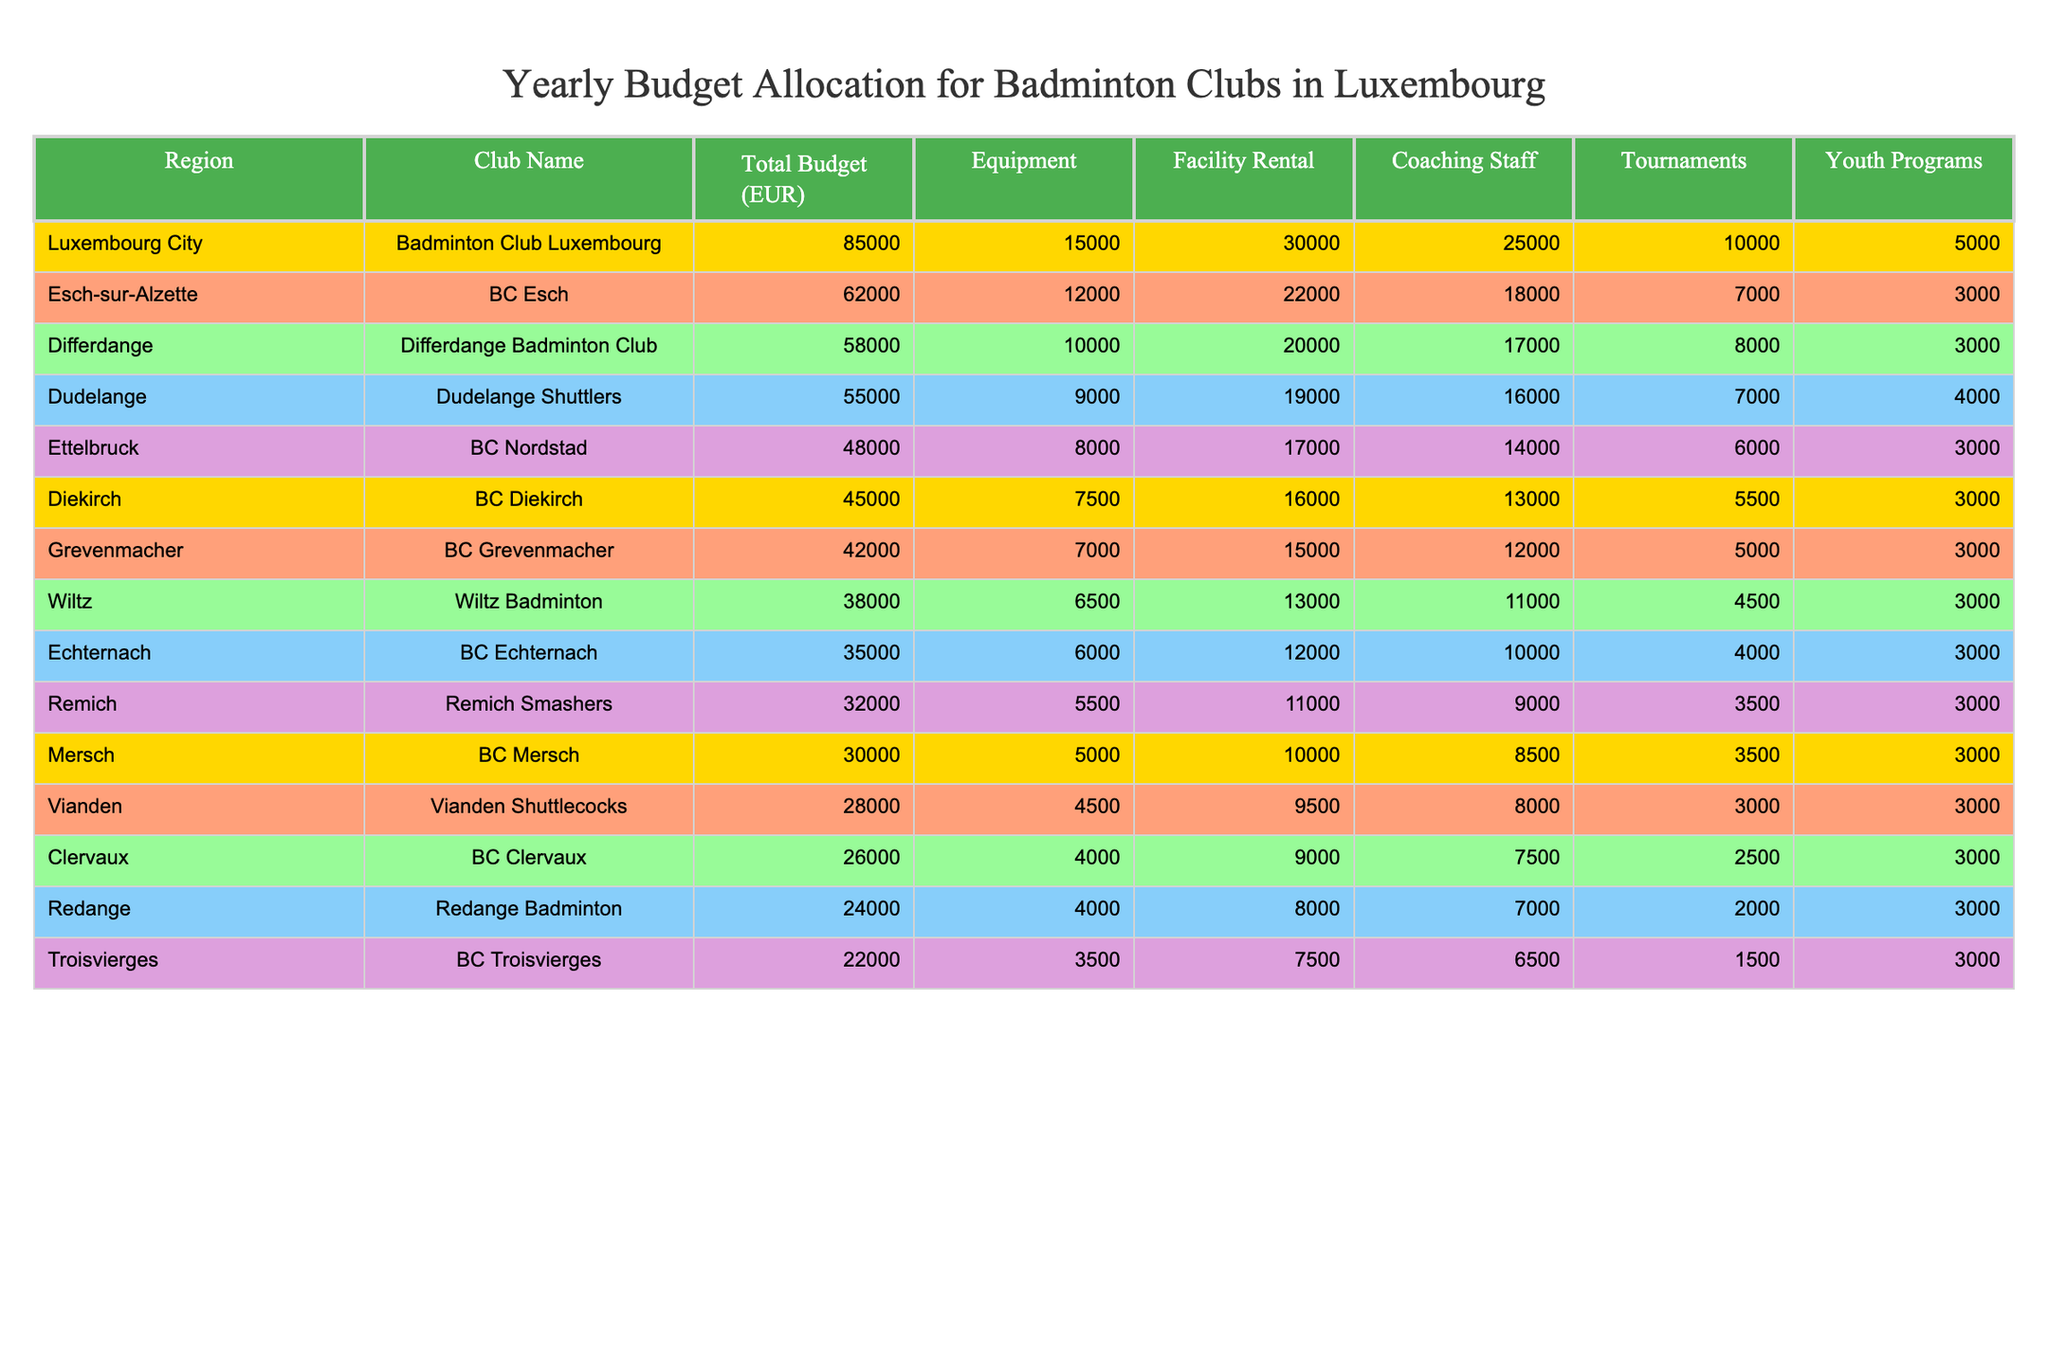What is the total budget for the Badminton Club Luxembourg? The total budget for the Badminton Club Luxembourg is listed in the table under "Total Budget (EUR)" for the region "Luxembourg City," which shows a value of 85,000 EUR.
Answer: 85,000 EUR Which club has the highest budget allocation? By examining the "Total Budget (EUR)" column, it is clear that the Badminton Club Luxembourg has the highest total budget of 85,000 EUR, compared to other clubs.
Answer: Badminton Club Luxembourg What percentage of the total budget does coaching staff make up for BC Esch? The total budget for BC Esch is 62,000 EUR, and the coaching staff allocation is 18,000 EUR. To find the percentage, divide 18,000 by 62,000 and multiply by 100: (18000/62000) * 100 = 29.03%.
Answer: 29.03% How much more does the Badminton Club Luxembourg spend on facility rental than on youth programs? The Badminton Club Luxembourg allocates 30,000 EUR for facility rental and 5,000 EUR for youth programs. The difference is calculated as 30,000 - 5,000 = 25,000 EUR.
Answer: 25,000 EUR What is the average total budget across all clubs listed? To calculate the average, first add all total budgets: 85,000 + 62,000 + 58,000 + 55,000 + 48,000 + 45,000 + 42,000 + 38,000 + 35,000 + 32,000 + 30,000 + 28,000 + 26,000 + 24,000 + 22,000 =  623,000 EUR. There are 15 clubs, so divide 623,000 by 15, which gives an average of 41,533.33 EUR.
Answer: 41,533.33 EUR Is the total budget for BC Grevenmacher higher than that for BC Vianden? The total budget for BC Grevenmacher is 42,000 EUR, and for BC Vianden, it is 28,000 EUR. Since 42,000 is greater than 28,000, the statement is true.
Answer: True Which region has the lowest budget allocation for their badminton club? By scanning through the "Total Budget (EUR)" column, it is found that the region with the lowest allocation is Troisvierges with a budget of 22,000 EUR.
Answer: Troisvierges What is the total equipment budget allocated to all clubs combined? The equipment budgets are: 15,000 + 12,000 + 10,000 + 9,000 + 8,000 + 7,500 + 7,000 + 6,500 + 6,000 + 5,500 + 5,000 + 4,500 + 4,000 + 4,000 + 3,500 =  65,500 EUR.
Answer: 65,500 EUR How much does the Dudelange Shuttlers spend on tournaments? The Dudelange Shuttlers allocate 7,000 EUR for tournaments as indicated in the "Tournaments" column.
Answer: 7,000 EUR If we consider only the clubs in the central region (Luxembourg City, Mersch, and Ettelbruck), what is the sum of their budgets? The budgets for these clubs are: 85,000 (Luxembourg City) + 30,000 (Mersch) + 48,000 (Ettelbruck) = 163,000 EUR.
Answer: 163,000 EUR Which club has a higher budget for youth programs: BC Diekirch or Differdange Badminton Club? BC Diekirch spends 3,000 EUR while Differdange Badminton Club also spends 3,000 EUR. Since both spend the same amount, neither has a higher budget.
Answer: Neither 